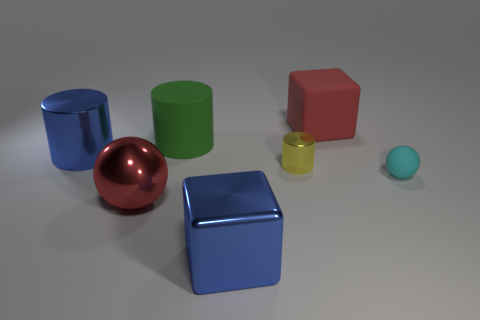Subtract all yellow metal cylinders. How many cylinders are left? 2 Subtract all yellow cylinders. How many cylinders are left? 2 Subtract all tiny cyan shiny blocks. Subtract all yellow shiny things. How many objects are left? 6 Add 3 big red metallic things. How many big red metallic things are left? 4 Add 1 green metal cylinders. How many green metal cylinders exist? 1 Add 1 small cyan objects. How many objects exist? 8 Subtract 0 brown cylinders. How many objects are left? 7 Subtract all spheres. How many objects are left? 5 Subtract 2 cylinders. How many cylinders are left? 1 Subtract all brown balls. Subtract all brown cylinders. How many balls are left? 2 